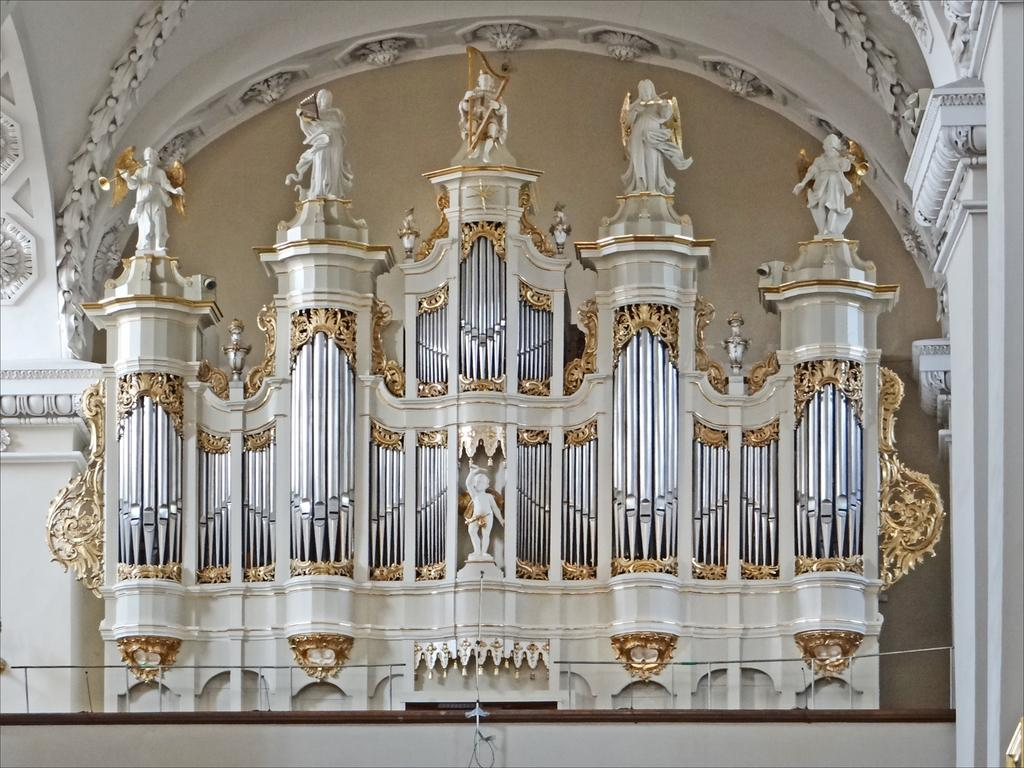What type of location is depicted in the image? The image shows an inner view of a building. What can be seen on the ceiling of the building? There are carvings on the ceiling. Are there any other notable features in the building? Yes, there are statues present. What color is the shirt worn by the statue in the image? There are no shirts or statues wearing shirts present in the image. 